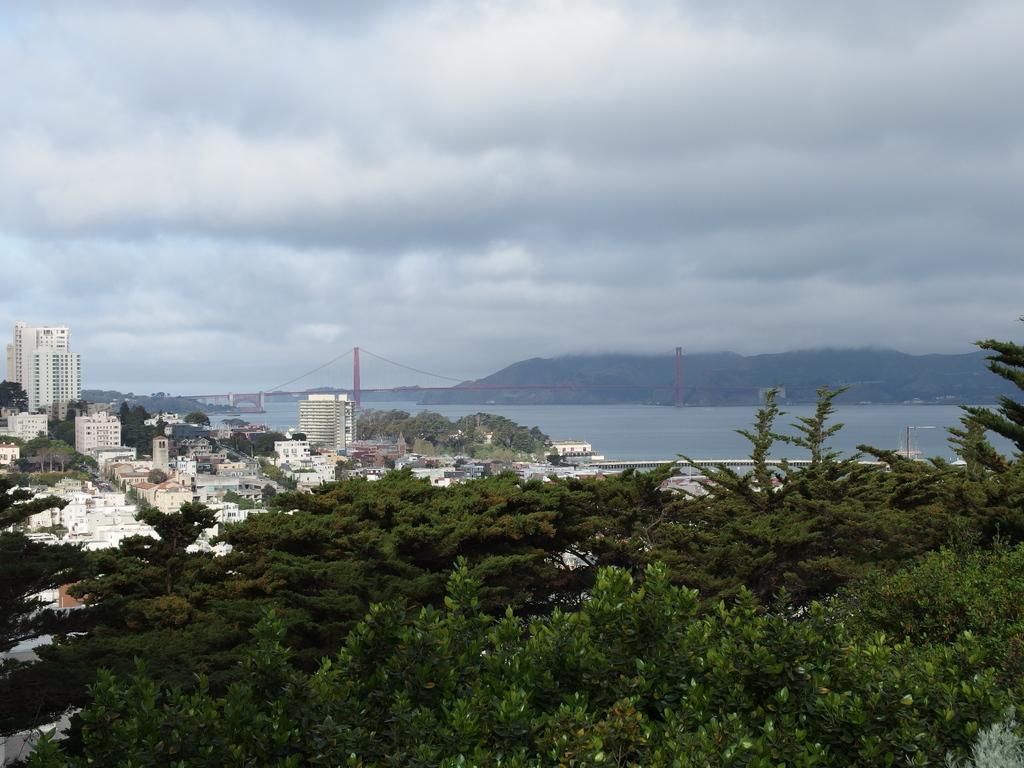Please provide a concise description of this image. In this image I can see number of trees which are green in color, number of buildings and the road. In the background I can see the bridge, the water, a mountain and the sky. 